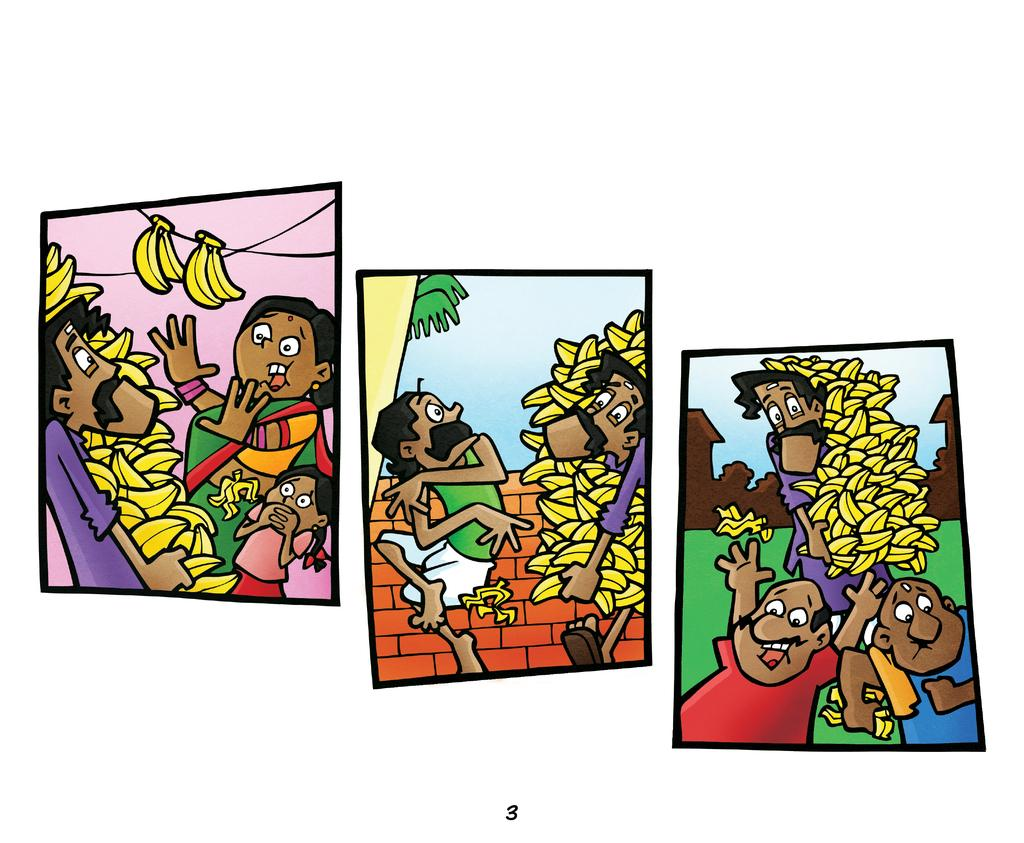How many pictures are present in the image? The image consists of three pictures. What type of characters are featured in each picture? Each picture contains cartoons. What is a common element present in each of the three pictures? Each picture also contains bananas. What type of vest is the cartoon character wearing in the image? There is no cartoon character wearing a vest in the image; the characters are not wearing any clothing. What type of band is playing music in the image? There is no band present in the image; it consists of three pictures featuring cartoons and bananas. 